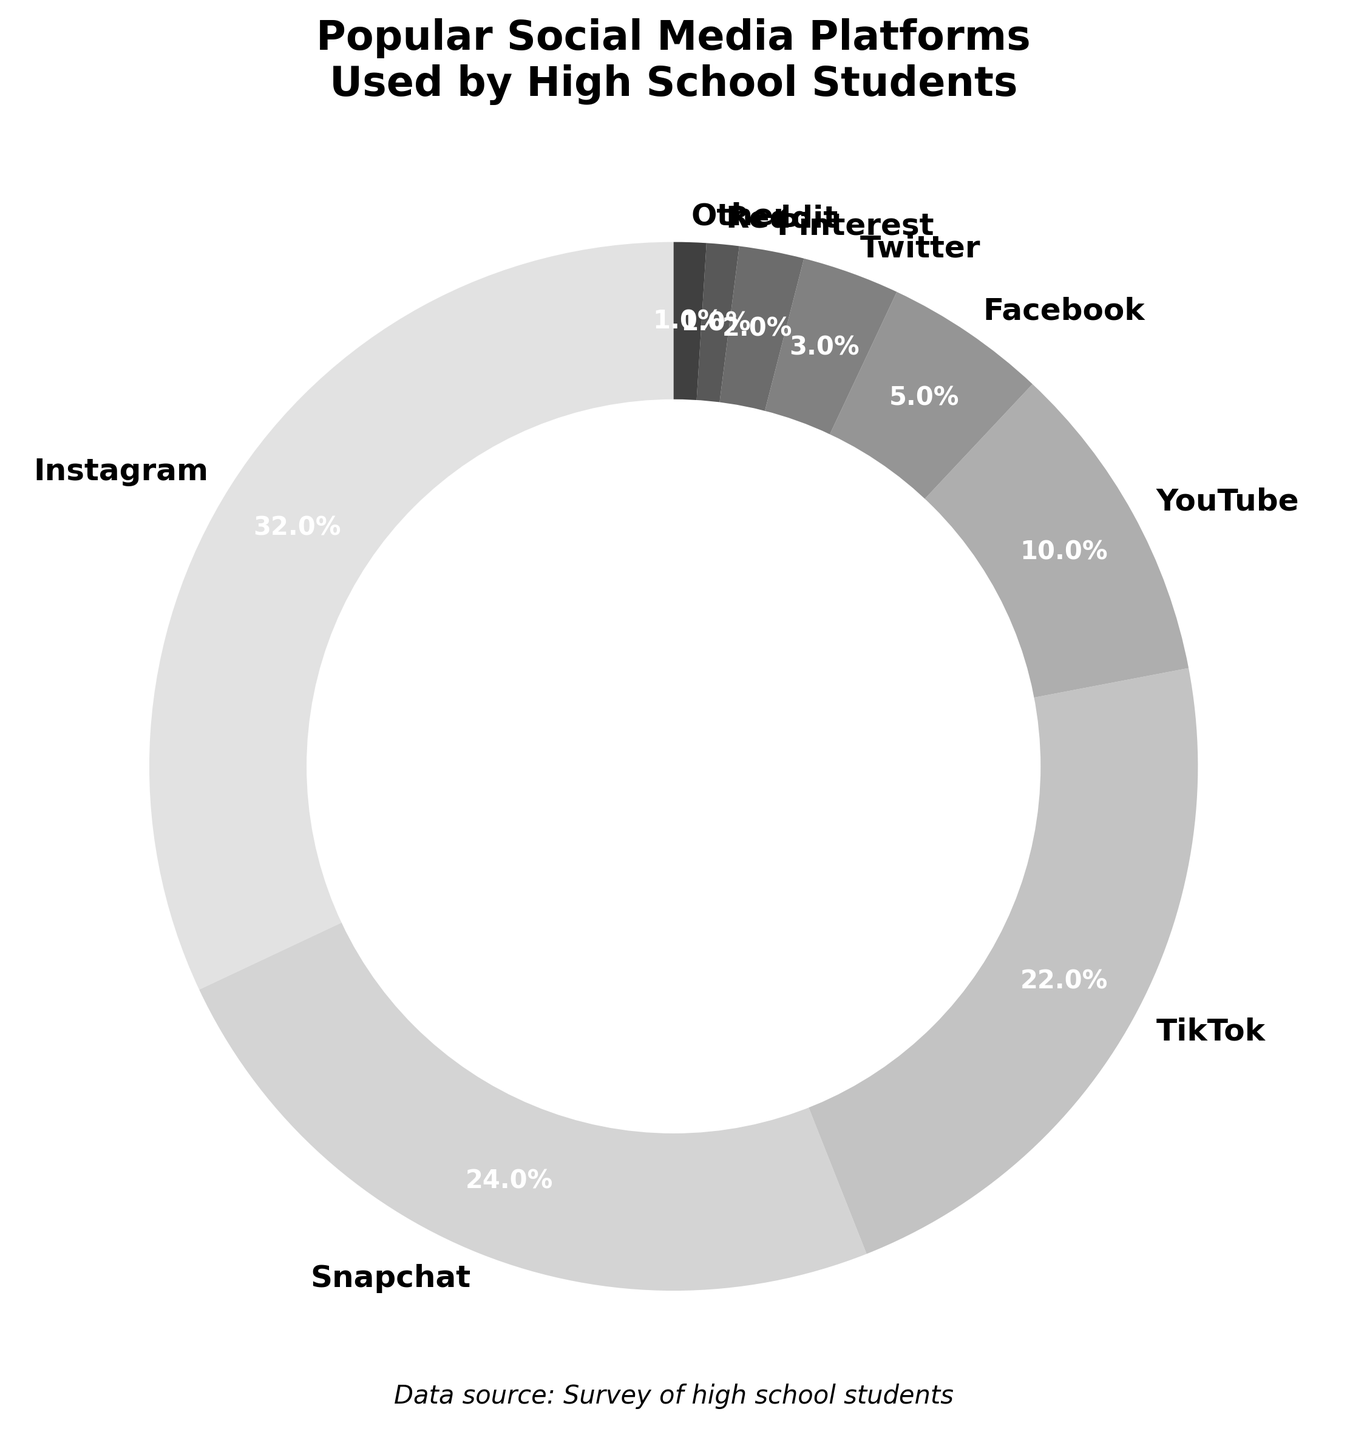Which platform has the highest usage percentage? Look at the largest slice of the pie chart and its corresponding label. Instagram holds the biggest slice at 32%.
Answer: Instagram Which platform has the second lowest usage percentage? Identify the smallest slices, excluding the absolute smallest. The smallest slice is Reddit with 1%, and the next smallest slice is Pinterest with 2%.
Answer: Pinterest How much more popular is Snapchat compared to Facebook? Find the percentages for both Snapchat (24%) and Facebook (5%). Subtract Facebook's percentage from Snapchat's percentage: 24 - 5 = 19.
Answer: 19% What is the combined usage percentage of TikTok and YouTube? Add the percentages for TikTok (22%) and YouTube (10%): 22 + 10 = 32.
Answer: 32% Which platforms together make up over half of the total usage? Add the percentages from largest to smallest until the sum is over 50%. Instagram (32%) + Snapchat (24%) = 56%, which is over half.
Answer: Instagram and Snapchat What is the average usage percentage of all platforms? Sum all the percentages and then divide by the number of platforms. The total is 100%, and there are 9 platforms: 100 / 9 ≈ 11.11.
Answer: 11.11% Which two platforms make up less than 5% of the total usage? Look at the smallest slices that together total less than 5%. Reddit (1%) and Other (1%) together make 2%, which is less than 5%.
Answer: Reddit and Other What is the difference in usage percentage between the most and least used platforms? Subtract the smallest percentage (Reddit, 1%) from the largest percentage (Instagram, 32%): 32 - 1 = 31.
Answer: 31% 